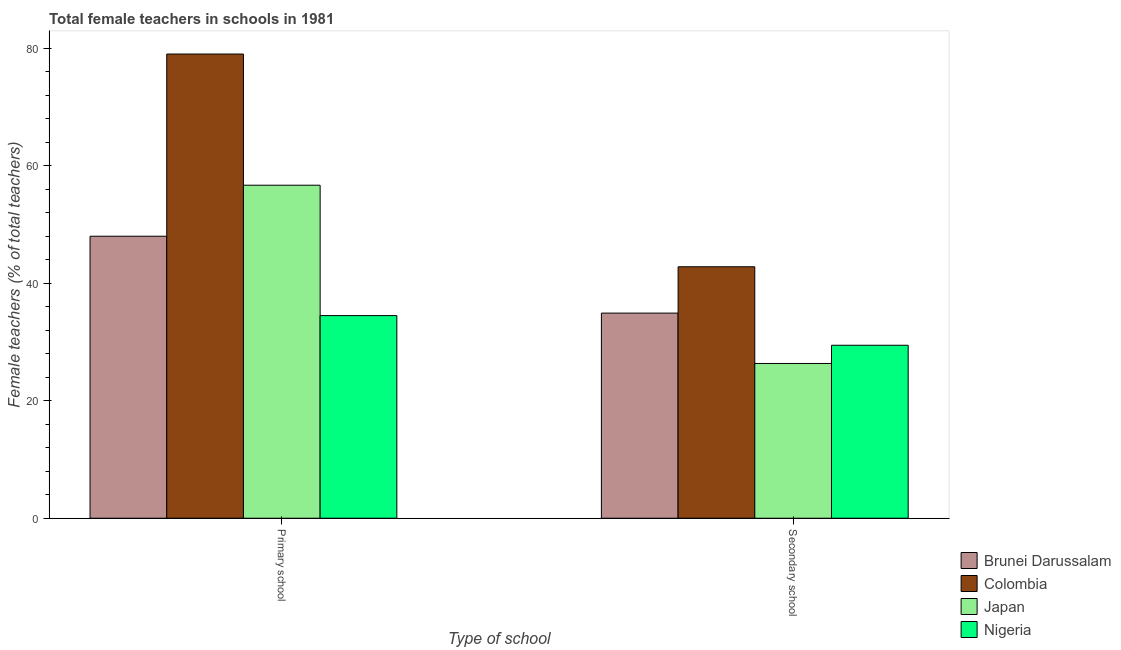How many different coloured bars are there?
Provide a succinct answer. 4. How many groups of bars are there?
Offer a very short reply. 2. How many bars are there on the 1st tick from the right?
Provide a succinct answer. 4. What is the label of the 1st group of bars from the left?
Your answer should be very brief. Primary school. Across all countries, what is the maximum percentage of female teachers in primary schools?
Offer a terse response. 79.01. Across all countries, what is the minimum percentage of female teachers in primary schools?
Offer a very short reply. 34.49. In which country was the percentage of female teachers in primary schools maximum?
Give a very brief answer. Colombia. In which country was the percentage of female teachers in secondary schools minimum?
Your response must be concise. Japan. What is the total percentage of female teachers in secondary schools in the graph?
Ensure brevity in your answer.  133.5. What is the difference between the percentage of female teachers in primary schools in Nigeria and that in Colombia?
Provide a short and direct response. -44.52. What is the difference between the percentage of female teachers in primary schools in Japan and the percentage of female teachers in secondary schools in Colombia?
Provide a short and direct response. 13.88. What is the average percentage of female teachers in primary schools per country?
Keep it short and to the point. 54.55. What is the difference between the percentage of female teachers in secondary schools and percentage of female teachers in primary schools in Nigeria?
Give a very brief answer. -5.05. What is the ratio of the percentage of female teachers in secondary schools in Colombia to that in Brunei Darussalam?
Provide a succinct answer. 1.23. In how many countries, is the percentage of female teachers in secondary schools greater than the average percentage of female teachers in secondary schools taken over all countries?
Give a very brief answer. 2. What does the 3rd bar from the right in Secondary school represents?
Give a very brief answer. Colombia. What is the difference between two consecutive major ticks on the Y-axis?
Provide a short and direct response. 20. Where does the legend appear in the graph?
Your answer should be compact. Bottom right. How many legend labels are there?
Offer a very short reply. 4. How are the legend labels stacked?
Your response must be concise. Vertical. What is the title of the graph?
Provide a short and direct response. Total female teachers in schools in 1981. What is the label or title of the X-axis?
Offer a terse response. Type of school. What is the label or title of the Y-axis?
Provide a short and direct response. Female teachers (% of total teachers). What is the Female teachers (% of total teachers) of Brunei Darussalam in Primary school?
Your answer should be compact. 48. What is the Female teachers (% of total teachers) in Colombia in Primary school?
Offer a very short reply. 79.01. What is the Female teachers (% of total teachers) in Japan in Primary school?
Offer a very short reply. 56.68. What is the Female teachers (% of total teachers) in Nigeria in Primary school?
Offer a terse response. 34.49. What is the Female teachers (% of total teachers) in Brunei Darussalam in Secondary school?
Keep it short and to the point. 34.92. What is the Female teachers (% of total teachers) of Colombia in Secondary school?
Provide a succinct answer. 42.8. What is the Female teachers (% of total teachers) of Japan in Secondary school?
Ensure brevity in your answer.  26.34. What is the Female teachers (% of total teachers) in Nigeria in Secondary school?
Your answer should be compact. 29.44. Across all Type of school, what is the maximum Female teachers (% of total teachers) of Colombia?
Your answer should be very brief. 79.01. Across all Type of school, what is the maximum Female teachers (% of total teachers) of Japan?
Your answer should be very brief. 56.68. Across all Type of school, what is the maximum Female teachers (% of total teachers) of Nigeria?
Give a very brief answer. 34.49. Across all Type of school, what is the minimum Female teachers (% of total teachers) in Brunei Darussalam?
Keep it short and to the point. 34.92. Across all Type of school, what is the minimum Female teachers (% of total teachers) of Colombia?
Provide a short and direct response. 42.8. Across all Type of school, what is the minimum Female teachers (% of total teachers) in Japan?
Offer a very short reply. 26.34. Across all Type of school, what is the minimum Female teachers (% of total teachers) in Nigeria?
Offer a terse response. 29.44. What is the total Female teachers (% of total teachers) in Brunei Darussalam in the graph?
Ensure brevity in your answer.  82.92. What is the total Female teachers (% of total teachers) in Colombia in the graph?
Provide a succinct answer. 121.81. What is the total Female teachers (% of total teachers) of Japan in the graph?
Your response must be concise. 83.02. What is the total Female teachers (% of total teachers) in Nigeria in the graph?
Keep it short and to the point. 63.93. What is the difference between the Female teachers (% of total teachers) of Brunei Darussalam in Primary school and that in Secondary school?
Your response must be concise. 13.08. What is the difference between the Female teachers (% of total teachers) of Colombia in Primary school and that in Secondary school?
Make the answer very short. 36.21. What is the difference between the Female teachers (% of total teachers) of Japan in Primary school and that in Secondary school?
Offer a terse response. 30.34. What is the difference between the Female teachers (% of total teachers) in Nigeria in Primary school and that in Secondary school?
Provide a short and direct response. 5.05. What is the difference between the Female teachers (% of total teachers) in Brunei Darussalam in Primary school and the Female teachers (% of total teachers) in Colombia in Secondary school?
Ensure brevity in your answer.  5.2. What is the difference between the Female teachers (% of total teachers) of Brunei Darussalam in Primary school and the Female teachers (% of total teachers) of Japan in Secondary school?
Your answer should be compact. 21.66. What is the difference between the Female teachers (% of total teachers) in Brunei Darussalam in Primary school and the Female teachers (% of total teachers) in Nigeria in Secondary school?
Your response must be concise. 18.56. What is the difference between the Female teachers (% of total teachers) of Colombia in Primary school and the Female teachers (% of total teachers) of Japan in Secondary school?
Provide a short and direct response. 52.67. What is the difference between the Female teachers (% of total teachers) of Colombia in Primary school and the Female teachers (% of total teachers) of Nigeria in Secondary school?
Offer a very short reply. 49.57. What is the difference between the Female teachers (% of total teachers) of Japan in Primary school and the Female teachers (% of total teachers) of Nigeria in Secondary school?
Make the answer very short. 27.24. What is the average Female teachers (% of total teachers) of Brunei Darussalam per Type of school?
Your answer should be compact. 41.46. What is the average Female teachers (% of total teachers) in Colombia per Type of school?
Provide a succinct answer. 60.91. What is the average Female teachers (% of total teachers) in Japan per Type of school?
Offer a very short reply. 41.51. What is the average Female teachers (% of total teachers) of Nigeria per Type of school?
Offer a very short reply. 31.97. What is the difference between the Female teachers (% of total teachers) in Brunei Darussalam and Female teachers (% of total teachers) in Colombia in Primary school?
Make the answer very short. -31.01. What is the difference between the Female teachers (% of total teachers) of Brunei Darussalam and Female teachers (% of total teachers) of Japan in Primary school?
Make the answer very short. -8.68. What is the difference between the Female teachers (% of total teachers) of Brunei Darussalam and Female teachers (% of total teachers) of Nigeria in Primary school?
Your answer should be very brief. 13.51. What is the difference between the Female teachers (% of total teachers) in Colombia and Female teachers (% of total teachers) in Japan in Primary school?
Provide a short and direct response. 22.33. What is the difference between the Female teachers (% of total teachers) of Colombia and Female teachers (% of total teachers) of Nigeria in Primary school?
Give a very brief answer. 44.52. What is the difference between the Female teachers (% of total teachers) in Japan and Female teachers (% of total teachers) in Nigeria in Primary school?
Offer a very short reply. 22.19. What is the difference between the Female teachers (% of total teachers) of Brunei Darussalam and Female teachers (% of total teachers) of Colombia in Secondary school?
Make the answer very short. -7.88. What is the difference between the Female teachers (% of total teachers) in Brunei Darussalam and Female teachers (% of total teachers) in Japan in Secondary school?
Your answer should be compact. 8.58. What is the difference between the Female teachers (% of total teachers) of Brunei Darussalam and Female teachers (% of total teachers) of Nigeria in Secondary school?
Provide a succinct answer. 5.47. What is the difference between the Female teachers (% of total teachers) of Colombia and Female teachers (% of total teachers) of Japan in Secondary school?
Offer a very short reply. 16.46. What is the difference between the Female teachers (% of total teachers) in Colombia and Female teachers (% of total teachers) in Nigeria in Secondary school?
Ensure brevity in your answer.  13.36. What is the difference between the Female teachers (% of total teachers) of Japan and Female teachers (% of total teachers) of Nigeria in Secondary school?
Your answer should be very brief. -3.1. What is the ratio of the Female teachers (% of total teachers) in Brunei Darussalam in Primary school to that in Secondary school?
Offer a terse response. 1.37. What is the ratio of the Female teachers (% of total teachers) in Colombia in Primary school to that in Secondary school?
Offer a terse response. 1.85. What is the ratio of the Female teachers (% of total teachers) of Japan in Primary school to that in Secondary school?
Offer a terse response. 2.15. What is the ratio of the Female teachers (% of total teachers) of Nigeria in Primary school to that in Secondary school?
Offer a very short reply. 1.17. What is the difference between the highest and the second highest Female teachers (% of total teachers) in Brunei Darussalam?
Give a very brief answer. 13.08. What is the difference between the highest and the second highest Female teachers (% of total teachers) of Colombia?
Ensure brevity in your answer.  36.21. What is the difference between the highest and the second highest Female teachers (% of total teachers) in Japan?
Give a very brief answer. 30.34. What is the difference between the highest and the second highest Female teachers (% of total teachers) of Nigeria?
Give a very brief answer. 5.05. What is the difference between the highest and the lowest Female teachers (% of total teachers) in Brunei Darussalam?
Ensure brevity in your answer.  13.08. What is the difference between the highest and the lowest Female teachers (% of total teachers) in Colombia?
Keep it short and to the point. 36.21. What is the difference between the highest and the lowest Female teachers (% of total teachers) in Japan?
Give a very brief answer. 30.34. What is the difference between the highest and the lowest Female teachers (% of total teachers) of Nigeria?
Your response must be concise. 5.05. 